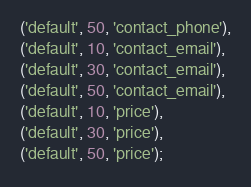<code> <loc_0><loc_0><loc_500><loc_500><_SQL_>('default', 50, 'contact_phone'),
('default', 10, 'contact_email'),
('default', 30, 'contact_email'),
('default', 50, 'contact_email'),
('default', 10, 'price'),
('default', 30, 'price'),
('default', 50, 'price');</code> 